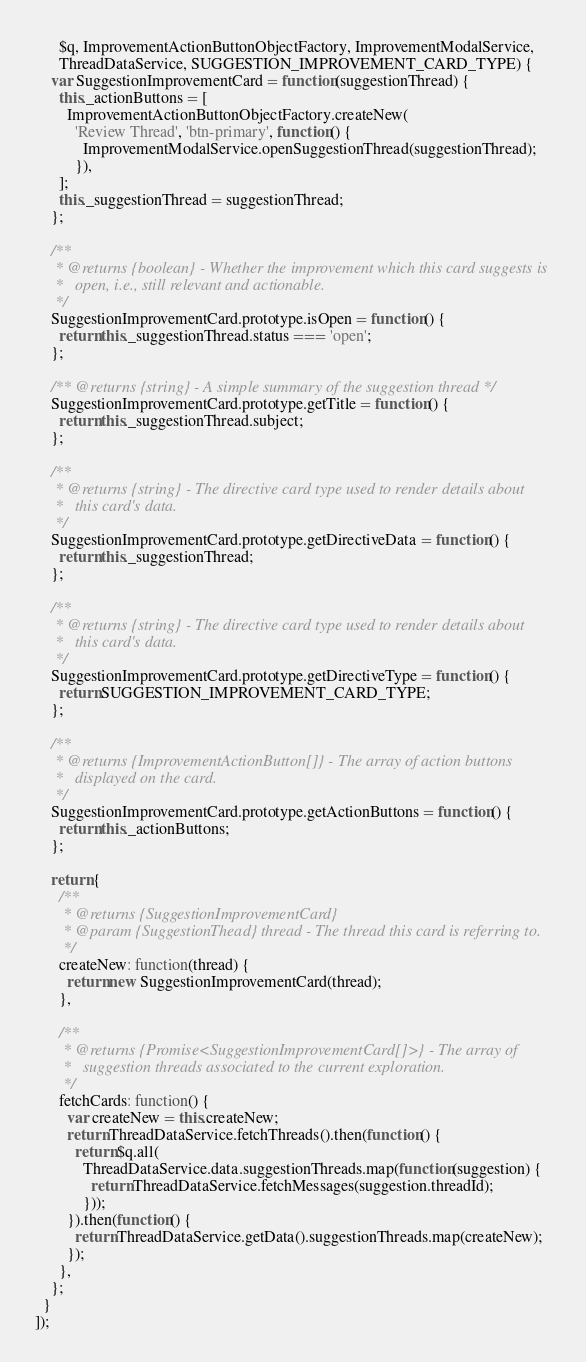Convert code to text. <code><loc_0><loc_0><loc_500><loc_500><_TypeScript_>      $q, ImprovementActionButtonObjectFactory, ImprovementModalService,
      ThreadDataService, SUGGESTION_IMPROVEMENT_CARD_TYPE) {
    var SuggestionImprovementCard = function(suggestionThread) {
      this._actionButtons = [
        ImprovementActionButtonObjectFactory.createNew(
          'Review Thread', 'btn-primary', function() {
            ImprovementModalService.openSuggestionThread(suggestionThread);
          }),
      ];
      this._suggestionThread = suggestionThread;
    };

    /**
     * @returns {boolean} - Whether the improvement which this card suggests is
     *   open, i.e., still relevant and actionable.
     */
    SuggestionImprovementCard.prototype.isOpen = function() {
      return this._suggestionThread.status === 'open';
    };

    /** @returns {string} - A simple summary of the suggestion thread */
    SuggestionImprovementCard.prototype.getTitle = function() {
      return this._suggestionThread.subject;
    };

    /**
     * @returns {string} - The directive card type used to render details about
     *   this card's data.
     */
    SuggestionImprovementCard.prototype.getDirectiveData = function() {
      return this._suggestionThread;
    };

    /**
     * @returns {string} - The directive card type used to render details about
     *   this card's data.
     */
    SuggestionImprovementCard.prototype.getDirectiveType = function() {
      return SUGGESTION_IMPROVEMENT_CARD_TYPE;
    };

    /**
     * @returns {ImprovementActionButton[]} - The array of action buttons
     *   displayed on the card.
     */
    SuggestionImprovementCard.prototype.getActionButtons = function() {
      return this._actionButtons;
    };

    return {
      /**
       * @returns {SuggestionImprovementCard}
       * @param {SuggestionThead} thread - The thread this card is referring to.
       */
      createNew: function(thread) {
        return new SuggestionImprovementCard(thread);
      },

      /**
       * @returns {Promise<SuggestionImprovementCard[]>} - The array of
       *   suggestion threads associated to the current exploration.
       */
      fetchCards: function() {
        var createNew = this.createNew;
        return ThreadDataService.fetchThreads().then(function() {
          return $q.all(
            ThreadDataService.data.suggestionThreads.map(function(suggestion) {
              return ThreadDataService.fetchMessages(suggestion.threadId);
            }));
        }).then(function() {
          return ThreadDataService.getData().suggestionThreads.map(createNew);
        });
      },
    };
  }
]);
</code> 